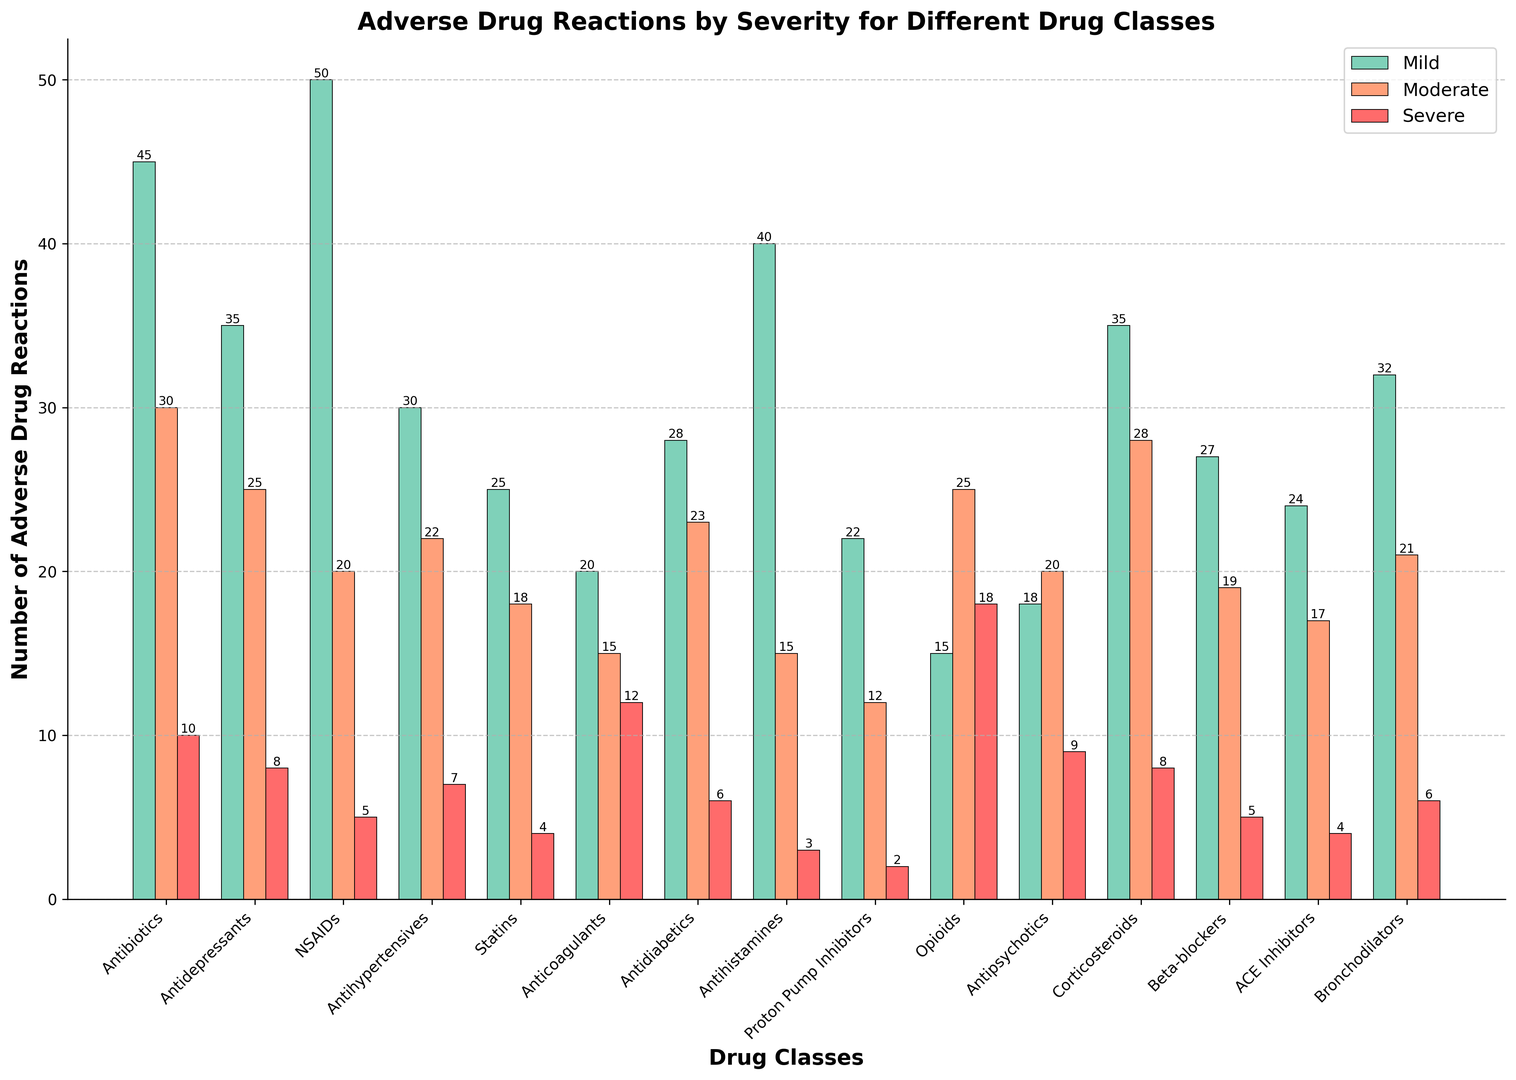Which drug class has the highest number of mild adverse drug reactions? According to the figure, the height of the bars represents the number of adverse drug reactions. The drug class with the highest mild reactions bar is NSAIDs.
Answer: NSAIDs Which drug class has the lowest number of moderate adverse drug reactions? By observing the bar heights for moderate adverse drug reactions, Proton Pump Inhibitors have the shortest bar.
Answer: Proton Pump Inhibitors Which drug class has the highest number of severe adverse drug reactions? The drug class with the highest number of severe adverse drug reactions is indicated by the tallest bar section colored in red. Opioids have the tallest severe reaction bar.
Answer: Opioids How many total adverse drug reactions are reported for Proton Pump Inhibitors? Sum the number of mild, moderate, and severe reactions for Proton Pump Inhibitors, which are 22, 12, and 2, respectively. Total = 22 + 12 + 2 = 36.
Answer: 36 Compare the number of severe adverse drug reactions between Opioids and Anticoagulants. The bar representing severe adverse drug reactions for Opioids is taller than that of Anticoagulants, indicating Opioids have more severe reactions.
Answer: Opioids Which drug class shows an equal number of moderate and severe adverse drug reactions? By comparing the heights of the bars, Opioids show the same height for moderate and severe reactions which are 25 and 18, respectively.
Answer: Opioids Calculate the average number of mild adverse drug reactions reported across all drug classes. Sum all the mild reaction numbers: 45+35+50+30+25+20+28+40+22+15+18+35+27+24+32 = 446. There are 15 drug classes, so the average is 446 / 15 = 29.73.
Answer: 29.73 Which drug class has the most balanced distribution of adverse drug reaction severity (i.e., similar numbers across mild, moderate, and severe)? Antipsychotics have similar bar heights for mild, moderate, and severe reactions indicating a balanced distribution.
Answer: Antipsychotics Determine the total number of adverse drug reactions reported for Antibiotics and compare it to those of Antidepressants. Sum the reactions for both classes: Antibiotics (45+30+10=85) and Antidepressants (35+25+8=68). 85 for Antibiotics is greater than 68 for Antidepressants.
Answer: Antibiotics Identify the drug class with the greatest difference between mild and severe reactions. NSAIDs have the greatest difference: Mild (50) - Severe (5) = 45, which is the largest difference among all the drug classes.
Answer: NSAIDs 